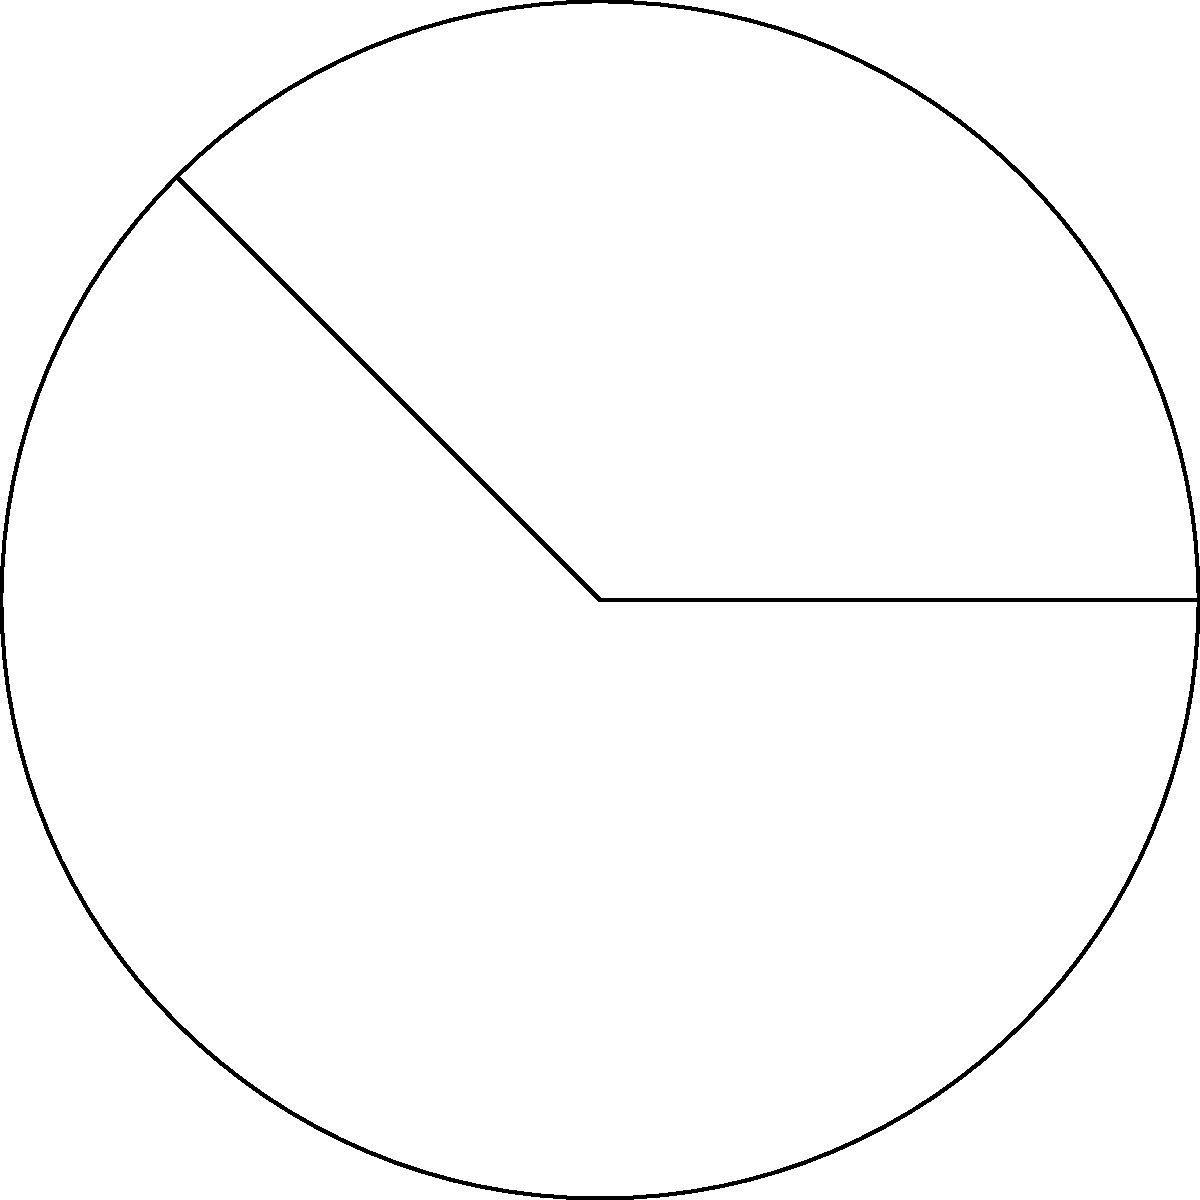You're designing a circular NFT artwork with a pie-chart-like segment. The full circle has a radius of 6 cm, and the segment spans an angle of 135°. What is the area of this segment in square centimeters? Round your answer to two decimal places. To find the area of a circular sector (segment), we can follow these steps:

1) The formula for the area of a circular sector is:

   $$A = \frac{\theta}{360°} \pi r^2$$

   Where $\theta$ is the central angle in degrees, and $r$ is the radius.

2) We're given:
   $\theta = 135°$
   $r = 6$ cm

3) Let's substitute these values into our formula:

   $$A = \frac{135°}{360°} \pi (6 \text{ cm})^2$$

4) Simplify:
   $$A = \frac{3}{8} \pi (36 \text{ cm}^2)$$
   $$A = \frac{27}{2} \pi \text{ cm}^2$$

5) Calculate:
   $$A \approx 42.41 \text{ cm}^2$$

6) Rounding to two decimal places:
   $$A \approx 42.41 \text{ cm}^2$$

Thus, the area of the segment is approximately 42.41 square centimeters.
Answer: 42.41 cm² 